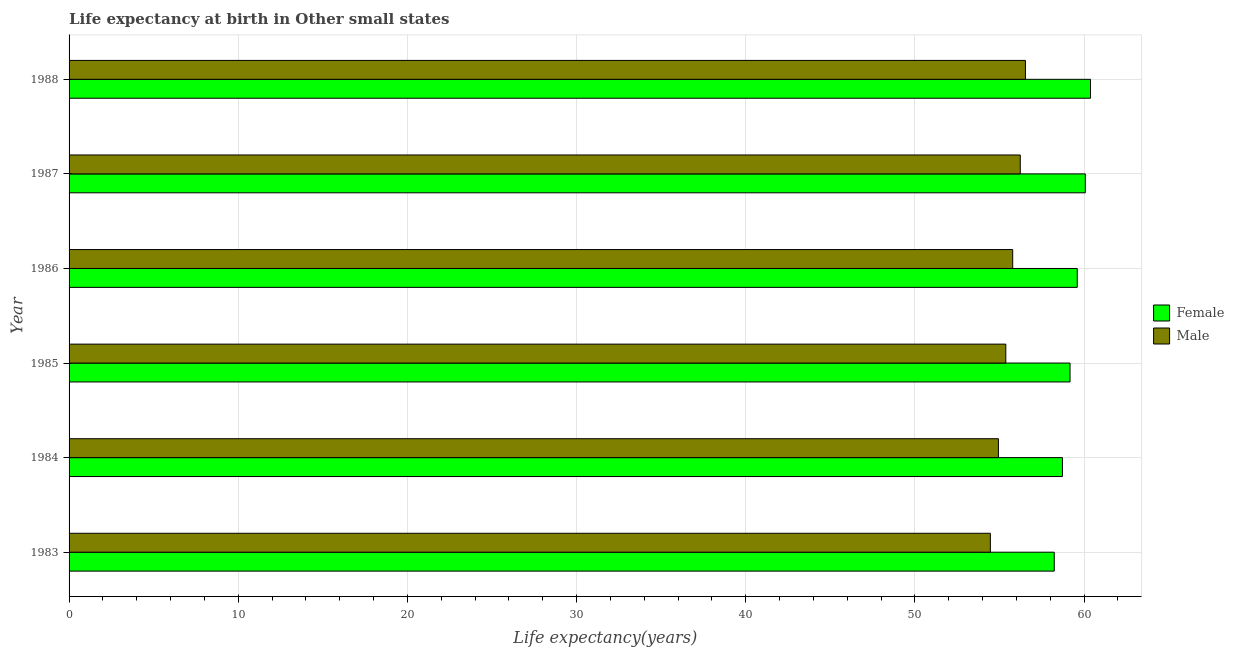How many groups of bars are there?
Offer a very short reply. 6. Are the number of bars on each tick of the Y-axis equal?
Provide a succinct answer. Yes. How many bars are there on the 1st tick from the top?
Keep it short and to the point. 2. How many bars are there on the 2nd tick from the bottom?
Your response must be concise. 2. What is the label of the 4th group of bars from the top?
Ensure brevity in your answer.  1985. What is the life expectancy(male) in 1986?
Ensure brevity in your answer.  55.78. Across all years, what is the maximum life expectancy(male)?
Your answer should be compact. 56.53. Across all years, what is the minimum life expectancy(female)?
Ensure brevity in your answer.  58.24. What is the total life expectancy(female) in the graph?
Your answer should be compact. 356.18. What is the difference between the life expectancy(female) in 1983 and that in 1984?
Provide a succinct answer. -0.48. What is the difference between the life expectancy(female) in 1985 and the life expectancy(male) in 1988?
Make the answer very short. 2.64. What is the average life expectancy(female) per year?
Offer a very short reply. 59.36. In the year 1988, what is the difference between the life expectancy(female) and life expectancy(male)?
Provide a succinct answer. 3.85. In how many years, is the life expectancy(male) greater than 26 years?
Offer a very short reply. 6. Is the difference between the life expectancy(male) in 1983 and 1985 greater than the difference between the life expectancy(female) in 1983 and 1985?
Offer a terse response. Yes. What is the difference between the highest and the second highest life expectancy(female)?
Offer a terse response. 0.31. What is the difference between the highest and the lowest life expectancy(female)?
Provide a short and direct response. 2.14. What does the 2nd bar from the bottom in 1988 represents?
Your response must be concise. Male. What is the difference between two consecutive major ticks on the X-axis?
Offer a terse response. 10. Does the graph contain grids?
Offer a terse response. Yes. How are the legend labels stacked?
Offer a terse response. Vertical. What is the title of the graph?
Keep it short and to the point. Life expectancy at birth in Other small states. Does "Goods" appear as one of the legend labels in the graph?
Make the answer very short. No. What is the label or title of the X-axis?
Give a very brief answer. Life expectancy(years). What is the label or title of the Y-axis?
Ensure brevity in your answer.  Year. What is the Life expectancy(years) in Female in 1983?
Offer a terse response. 58.24. What is the Life expectancy(years) of Male in 1983?
Provide a succinct answer. 54.46. What is the Life expectancy(years) in Female in 1984?
Offer a terse response. 58.72. What is the Life expectancy(years) of Male in 1984?
Offer a very short reply. 54.94. What is the Life expectancy(years) of Female in 1985?
Give a very brief answer. 59.17. What is the Life expectancy(years) of Male in 1985?
Keep it short and to the point. 55.37. What is the Life expectancy(years) of Female in 1986?
Ensure brevity in your answer.  59.6. What is the Life expectancy(years) of Male in 1986?
Make the answer very short. 55.78. What is the Life expectancy(years) of Female in 1987?
Give a very brief answer. 60.07. What is the Life expectancy(years) in Male in 1987?
Keep it short and to the point. 56.23. What is the Life expectancy(years) in Female in 1988?
Offer a very short reply. 60.38. What is the Life expectancy(years) of Male in 1988?
Give a very brief answer. 56.53. Across all years, what is the maximum Life expectancy(years) of Female?
Offer a very short reply. 60.38. Across all years, what is the maximum Life expectancy(years) of Male?
Your answer should be compact. 56.53. Across all years, what is the minimum Life expectancy(years) in Female?
Ensure brevity in your answer.  58.24. Across all years, what is the minimum Life expectancy(years) in Male?
Your answer should be very brief. 54.46. What is the total Life expectancy(years) of Female in the graph?
Make the answer very short. 356.18. What is the total Life expectancy(years) in Male in the graph?
Your answer should be compact. 333.31. What is the difference between the Life expectancy(years) in Female in 1983 and that in 1984?
Your answer should be very brief. -0.48. What is the difference between the Life expectancy(years) in Male in 1983 and that in 1984?
Provide a short and direct response. -0.48. What is the difference between the Life expectancy(years) in Female in 1983 and that in 1985?
Your answer should be very brief. -0.93. What is the difference between the Life expectancy(years) of Male in 1983 and that in 1985?
Offer a terse response. -0.91. What is the difference between the Life expectancy(years) in Female in 1983 and that in 1986?
Your response must be concise. -1.36. What is the difference between the Life expectancy(years) in Male in 1983 and that in 1986?
Keep it short and to the point. -1.32. What is the difference between the Life expectancy(years) of Female in 1983 and that in 1987?
Give a very brief answer. -1.84. What is the difference between the Life expectancy(years) in Male in 1983 and that in 1987?
Make the answer very short. -1.77. What is the difference between the Life expectancy(years) in Female in 1983 and that in 1988?
Ensure brevity in your answer.  -2.14. What is the difference between the Life expectancy(years) in Male in 1983 and that in 1988?
Ensure brevity in your answer.  -2.07. What is the difference between the Life expectancy(years) in Female in 1984 and that in 1985?
Ensure brevity in your answer.  -0.45. What is the difference between the Life expectancy(years) of Male in 1984 and that in 1985?
Ensure brevity in your answer.  -0.44. What is the difference between the Life expectancy(years) of Female in 1984 and that in 1986?
Your response must be concise. -0.88. What is the difference between the Life expectancy(years) of Male in 1984 and that in 1986?
Offer a terse response. -0.84. What is the difference between the Life expectancy(years) in Female in 1984 and that in 1987?
Make the answer very short. -1.35. What is the difference between the Life expectancy(years) in Male in 1984 and that in 1987?
Keep it short and to the point. -1.29. What is the difference between the Life expectancy(years) in Female in 1984 and that in 1988?
Make the answer very short. -1.66. What is the difference between the Life expectancy(years) in Male in 1984 and that in 1988?
Keep it short and to the point. -1.6. What is the difference between the Life expectancy(years) of Female in 1985 and that in 1986?
Your response must be concise. -0.43. What is the difference between the Life expectancy(years) of Male in 1985 and that in 1986?
Make the answer very short. -0.41. What is the difference between the Life expectancy(years) in Female in 1985 and that in 1987?
Keep it short and to the point. -0.9. What is the difference between the Life expectancy(years) of Male in 1985 and that in 1987?
Offer a very short reply. -0.86. What is the difference between the Life expectancy(years) in Female in 1985 and that in 1988?
Make the answer very short. -1.21. What is the difference between the Life expectancy(years) in Male in 1985 and that in 1988?
Offer a terse response. -1.16. What is the difference between the Life expectancy(years) of Female in 1986 and that in 1987?
Provide a short and direct response. -0.48. What is the difference between the Life expectancy(years) of Male in 1986 and that in 1987?
Give a very brief answer. -0.45. What is the difference between the Life expectancy(years) in Female in 1986 and that in 1988?
Offer a very short reply. -0.78. What is the difference between the Life expectancy(years) in Male in 1986 and that in 1988?
Your answer should be compact. -0.75. What is the difference between the Life expectancy(years) of Female in 1987 and that in 1988?
Offer a very short reply. -0.31. What is the difference between the Life expectancy(years) of Male in 1987 and that in 1988?
Give a very brief answer. -0.3. What is the difference between the Life expectancy(years) in Female in 1983 and the Life expectancy(years) in Male in 1984?
Offer a terse response. 3.3. What is the difference between the Life expectancy(years) of Female in 1983 and the Life expectancy(years) of Male in 1985?
Give a very brief answer. 2.86. What is the difference between the Life expectancy(years) in Female in 1983 and the Life expectancy(years) in Male in 1986?
Offer a very short reply. 2.46. What is the difference between the Life expectancy(years) of Female in 1983 and the Life expectancy(years) of Male in 1987?
Provide a succinct answer. 2.01. What is the difference between the Life expectancy(years) of Female in 1983 and the Life expectancy(years) of Male in 1988?
Ensure brevity in your answer.  1.7. What is the difference between the Life expectancy(years) of Female in 1984 and the Life expectancy(years) of Male in 1985?
Provide a succinct answer. 3.35. What is the difference between the Life expectancy(years) of Female in 1984 and the Life expectancy(years) of Male in 1986?
Your answer should be compact. 2.94. What is the difference between the Life expectancy(years) of Female in 1984 and the Life expectancy(years) of Male in 1987?
Give a very brief answer. 2.49. What is the difference between the Life expectancy(years) of Female in 1984 and the Life expectancy(years) of Male in 1988?
Your answer should be compact. 2.19. What is the difference between the Life expectancy(years) of Female in 1985 and the Life expectancy(years) of Male in 1986?
Your answer should be very brief. 3.39. What is the difference between the Life expectancy(years) of Female in 1985 and the Life expectancy(years) of Male in 1987?
Provide a short and direct response. 2.94. What is the difference between the Life expectancy(years) in Female in 1985 and the Life expectancy(years) in Male in 1988?
Provide a short and direct response. 2.64. What is the difference between the Life expectancy(years) in Female in 1986 and the Life expectancy(years) in Male in 1987?
Your answer should be very brief. 3.37. What is the difference between the Life expectancy(years) in Female in 1986 and the Life expectancy(years) in Male in 1988?
Make the answer very short. 3.06. What is the difference between the Life expectancy(years) of Female in 1987 and the Life expectancy(years) of Male in 1988?
Your response must be concise. 3.54. What is the average Life expectancy(years) of Female per year?
Provide a short and direct response. 59.36. What is the average Life expectancy(years) of Male per year?
Make the answer very short. 55.55. In the year 1983, what is the difference between the Life expectancy(years) in Female and Life expectancy(years) in Male?
Provide a short and direct response. 3.78. In the year 1984, what is the difference between the Life expectancy(years) of Female and Life expectancy(years) of Male?
Your answer should be very brief. 3.78. In the year 1985, what is the difference between the Life expectancy(years) in Female and Life expectancy(years) in Male?
Your response must be concise. 3.8. In the year 1986, what is the difference between the Life expectancy(years) in Female and Life expectancy(years) in Male?
Your answer should be very brief. 3.82. In the year 1987, what is the difference between the Life expectancy(years) of Female and Life expectancy(years) of Male?
Keep it short and to the point. 3.84. In the year 1988, what is the difference between the Life expectancy(years) of Female and Life expectancy(years) of Male?
Make the answer very short. 3.85. What is the ratio of the Life expectancy(years) in Female in 1983 to that in 1985?
Your answer should be compact. 0.98. What is the ratio of the Life expectancy(years) of Male in 1983 to that in 1985?
Offer a terse response. 0.98. What is the ratio of the Life expectancy(years) of Female in 1983 to that in 1986?
Give a very brief answer. 0.98. What is the ratio of the Life expectancy(years) of Male in 1983 to that in 1986?
Your answer should be compact. 0.98. What is the ratio of the Life expectancy(years) of Female in 1983 to that in 1987?
Keep it short and to the point. 0.97. What is the ratio of the Life expectancy(years) in Male in 1983 to that in 1987?
Offer a very short reply. 0.97. What is the ratio of the Life expectancy(years) in Female in 1983 to that in 1988?
Your response must be concise. 0.96. What is the ratio of the Life expectancy(years) of Male in 1983 to that in 1988?
Your answer should be compact. 0.96. What is the ratio of the Life expectancy(years) of Female in 1984 to that in 1985?
Your response must be concise. 0.99. What is the ratio of the Life expectancy(years) of Male in 1984 to that in 1985?
Give a very brief answer. 0.99. What is the ratio of the Life expectancy(years) in Male in 1984 to that in 1986?
Keep it short and to the point. 0.98. What is the ratio of the Life expectancy(years) in Female in 1984 to that in 1987?
Provide a short and direct response. 0.98. What is the ratio of the Life expectancy(years) of Female in 1984 to that in 1988?
Provide a succinct answer. 0.97. What is the ratio of the Life expectancy(years) of Male in 1984 to that in 1988?
Offer a terse response. 0.97. What is the ratio of the Life expectancy(years) in Male in 1985 to that in 1986?
Offer a terse response. 0.99. What is the ratio of the Life expectancy(years) in Female in 1985 to that in 1987?
Your answer should be compact. 0.98. What is the ratio of the Life expectancy(years) in Female in 1985 to that in 1988?
Offer a very short reply. 0.98. What is the ratio of the Life expectancy(years) in Male in 1985 to that in 1988?
Your answer should be compact. 0.98. What is the ratio of the Life expectancy(years) of Female in 1986 to that in 1987?
Your response must be concise. 0.99. What is the ratio of the Life expectancy(years) of Male in 1986 to that in 1987?
Your response must be concise. 0.99. What is the ratio of the Life expectancy(years) in Male in 1986 to that in 1988?
Ensure brevity in your answer.  0.99. What is the difference between the highest and the second highest Life expectancy(years) in Female?
Provide a short and direct response. 0.31. What is the difference between the highest and the second highest Life expectancy(years) in Male?
Provide a succinct answer. 0.3. What is the difference between the highest and the lowest Life expectancy(years) of Female?
Your answer should be very brief. 2.14. What is the difference between the highest and the lowest Life expectancy(years) in Male?
Offer a very short reply. 2.07. 